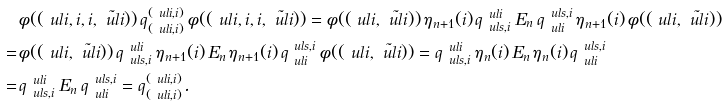<formula> <loc_0><loc_0><loc_500><loc_500>& \phi ( ( \ u l { i } , i , i , \tilde { \ u l { i } } ) ) \, q ^ { ( \ u l { i } , i ) } _ { ( \ u l { i } , i ) } \, \phi ( ( \ u l { i } , i , i , \tilde { \ u l { i } } ) ) = \phi ( ( \ u l { i } , \tilde { \ u l { i } } ) ) \, \eta _ { n + 1 } ( i ) \, q ^ { \ u l { i } } _ { \ u l { s } , i } \, E _ { n } \, q ^ { \ u l { s } , i } _ { \ u l { i } } \, \eta _ { n + 1 } ( i ) \, \phi ( ( \ u l { i } , \tilde { \ u l { i } } ) ) \\ = \, & \phi ( ( \ u l { i } , \tilde { \ u l { i } } ) ) \, q ^ { \ u l { i } } _ { \ u l { s } , i } \, \eta _ { n + 1 } ( i ) \, E _ { n } \, \eta _ { n + 1 } ( i ) \, q ^ { \ u l { s } , i } _ { \ u l { i } } \, \phi ( ( \ u l { i } , \tilde { \ u l { i } } ) ) = q ^ { \ u l { i } } _ { \ u l { s } , i } \, \eta _ { n } ( i ) \, E _ { n } \, \eta _ { n } ( i ) \, q ^ { \ u l { s } , i } _ { \ u l { i } } \\ = \, & q ^ { \ u l { i } } _ { \ u l { s } , i } \, E _ { n } \, q ^ { \ u l { s } , i } _ { \ u l { i } } = q ^ { ( \ u l { i } , i ) } _ { ( \ u l { i } , i ) } .</formula> 